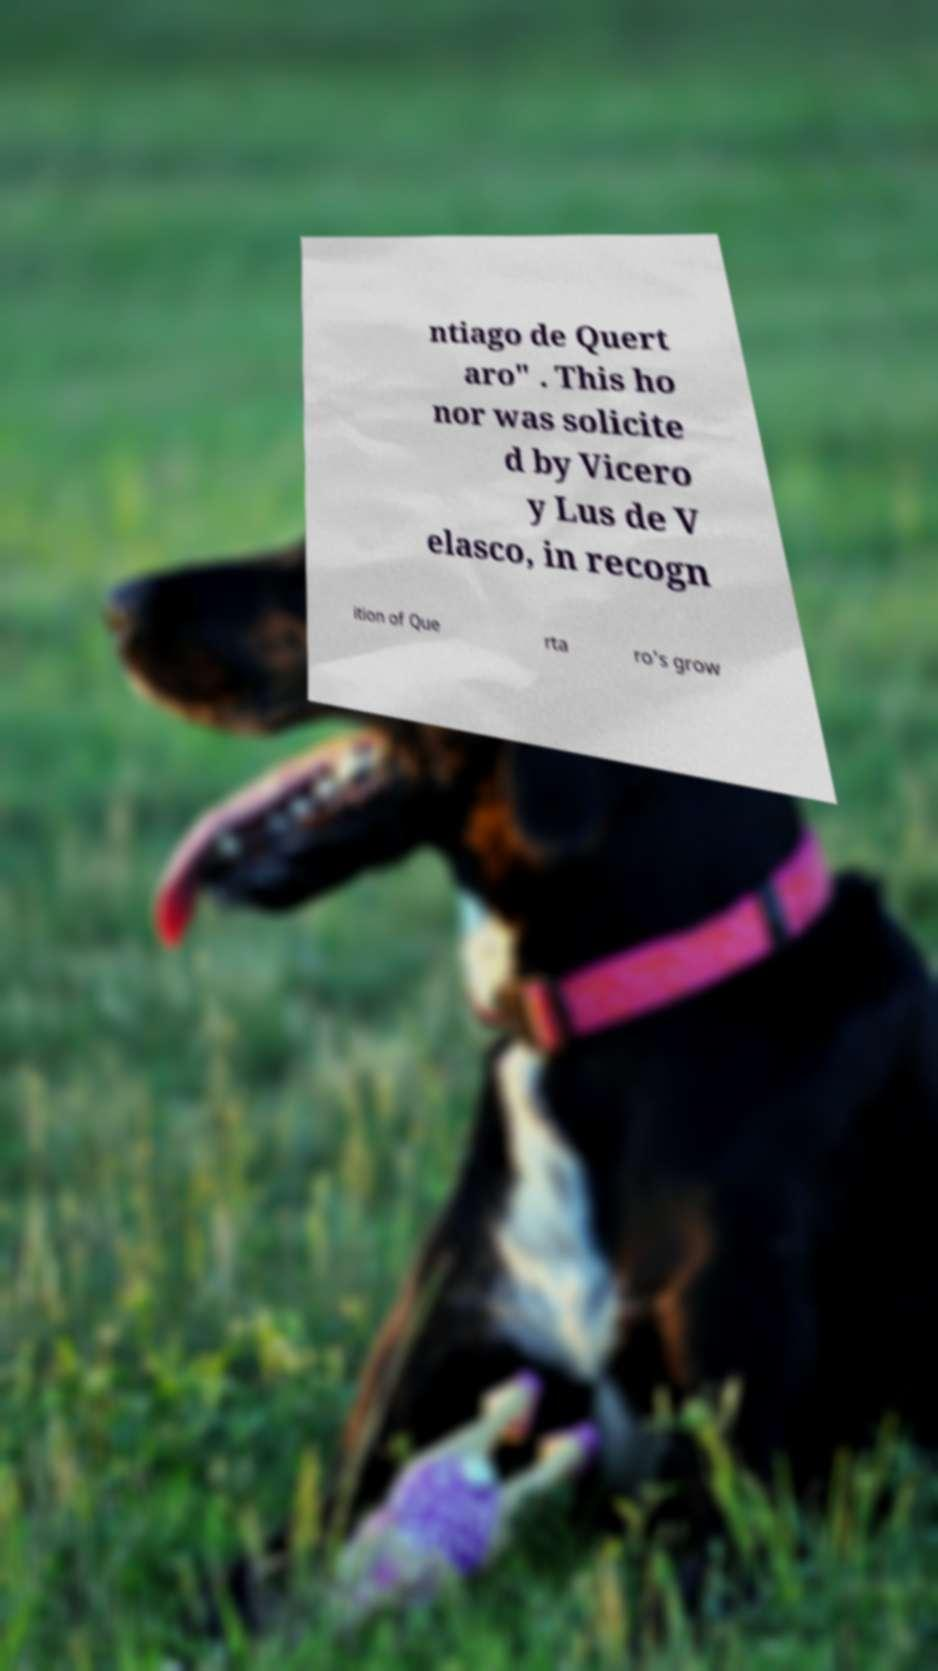Please identify and transcribe the text found in this image. ntiago de Quert aro" . This ho nor was solicite d by Vicero y Lus de V elasco, in recogn ition of Que rta ro's grow 